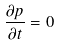<formula> <loc_0><loc_0><loc_500><loc_500>\frac { \partial p } { \partial t } = 0</formula> 